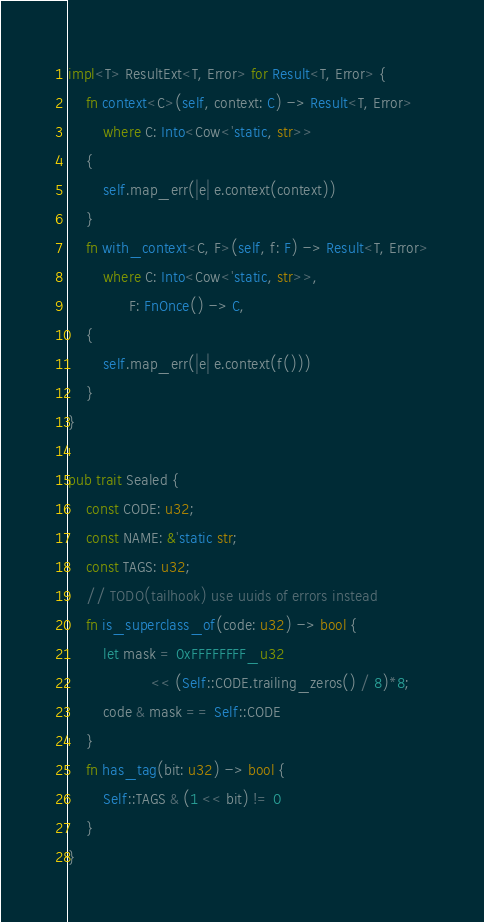Convert code to text. <code><loc_0><loc_0><loc_500><loc_500><_Rust_>
impl<T> ResultExt<T, Error> for Result<T, Error> {
    fn context<C>(self, context: C) -> Result<T, Error>
        where C: Into<Cow<'static, str>>
    {
        self.map_err(|e| e.context(context))
    }
    fn with_context<C, F>(self, f: F) -> Result<T, Error>
        where C: Into<Cow<'static, str>>,
              F: FnOnce() -> C,
    {
        self.map_err(|e| e.context(f()))
    }
}

pub trait Sealed {
    const CODE: u32;
    const NAME: &'static str;
    const TAGS: u32;
    // TODO(tailhook) use uuids of errors instead
    fn is_superclass_of(code: u32) -> bool {
        let mask = 0xFFFFFFFF_u32
                   << (Self::CODE.trailing_zeros() / 8)*8;
        code & mask == Self::CODE
    }
    fn has_tag(bit: u32) -> bool {
        Self::TAGS & (1 << bit) != 0
    }
}
</code> 